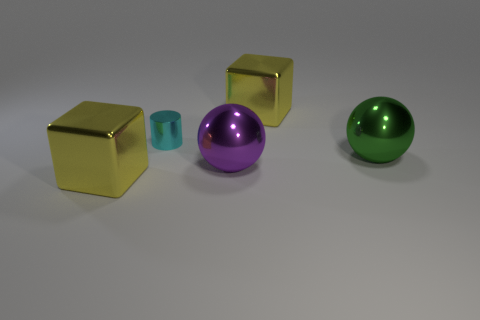Is there anything else that has the same shape as the purple metallic object?
Offer a very short reply. Yes. There is a sphere that is to the right of the big purple metallic thing; what is it made of?
Offer a very short reply. Metal. Is there any other thing that is the same size as the purple shiny thing?
Offer a very short reply. Yes. There is a cyan metallic cylinder; are there any blocks left of it?
Keep it short and to the point. Yes. What shape is the purple metal object?
Provide a succinct answer. Sphere. How many objects are either metal cubes that are in front of the tiny cylinder or large purple objects?
Your response must be concise. 2. How many other things are the same color as the tiny metallic thing?
Provide a succinct answer. 0. There is a tiny metal cylinder; is its color the same as the big cube on the left side of the cyan shiny thing?
Give a very brief answer. No. The other big object that is the same shape as the large purple thing is what color?
Your answer should be compact. Green. Does the cyan cylinder have the same material as the big cube that is in front of the green metallic sphere?
Provide a succinct answer. Yes. 